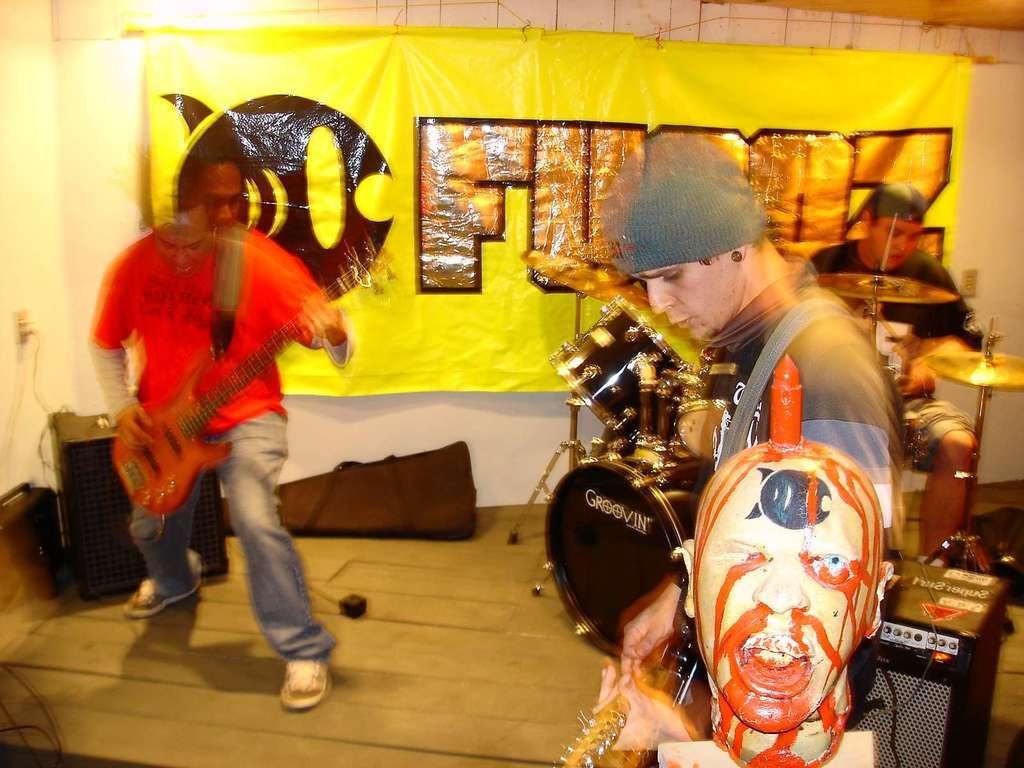Can you describe this image briefly? In this image we can see these people are performing different kind of instrument. 